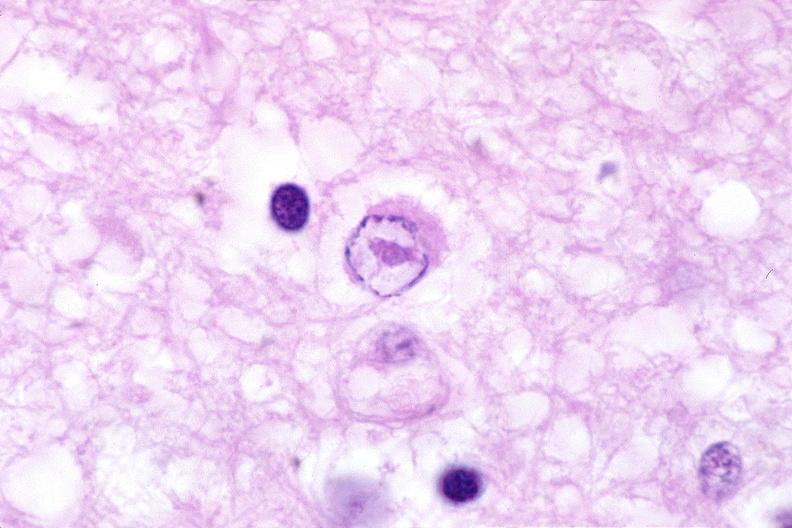where is this?
Answer the question using a single word or phrase. Nervous 